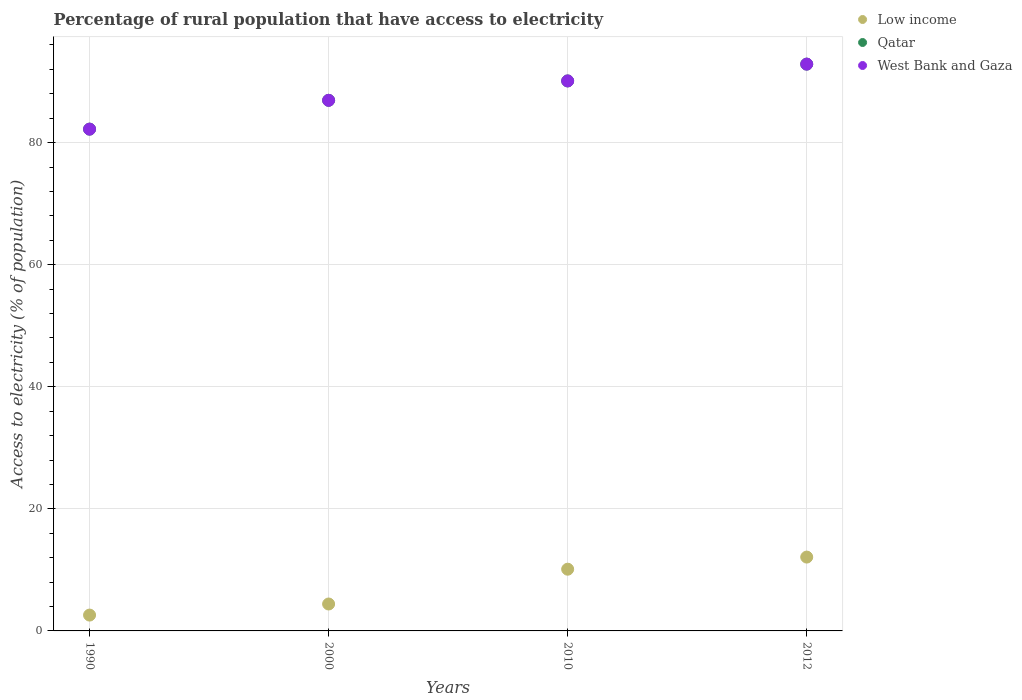Is the number of dotlines equal to the number of legend labels?
Your response must be concise. Yes. What is the percentage of rural population that have access to electricity in Low income in 2000?
Provide a succinct answer. 4.41. Across all years, what is the maximum percentage of rural population that have access to electricity in West Bank and Gaza?
Offer a very short reply. 92.85. Across all years, what is the minimum percentage of rural population that have access to electricity in Qatar?
Give a very brief answer. 82.2. In which year was the percentage of rural population that have access to electricity in West Bank and Gaza minimum?
Your answer should be compact. 1990. What is the total percentage of rural population that have access to electricity in West Bank and Gaza in the graph?
Provide a short and direct response. 352.08. What is the difference between the percentage of rural population that have access to electricity in Qatar in 2000 and that in 2012?
Your answer should be very brief. -5.93. What is the difference between the percentage of rural population that have access to electricity in West Bank and Gaza in 2000 and the percentage of rural population that have access to electricity in Qatar in 1990?
Keep it short and to the point. 4.72. What is the average percentage of rural population that have access to electricity in Qatar per year?
Ensure brevity in your answer.  88.02. In the year 2010, what is the difference between the percentage of rural population that have access to electricity in Low income and percentage of rural population that have access to electricity in Qatar?
Provide a short and direct response. -79.99. In how many years, is the percentage of rural population that have access to electricity in West Bank and Gaza greater than 84 %?
Your answer should be compact. 3. What is the ratio of the percentage of rural population that have access to electricity in Low income in 2010 to that in 2012?
Provide a succinct answer. 0.84. What is the difference between the highest and the second highest percentage of rural population that have access to electricity in Low income?
Offer a very short reply. 1.98. What is the difference between the highest and the lowest percentage of rural population that have access to electricity in Low income?
Make the answer very short. 9.5. In how many years, is the percentage of rural population that have access to electricity in Low income greater than the average percentage of rural population that have access to electricity in Low income taken over all years?
Keep it short and to the point. 2. Is it the case that in every year, the sum of the percentage of rural population that have access to electricity in Low income and percentage of rural population that have access to electricity in Qatar  is greater than the percentage of rural population that have access to electricity in West Bank and Gaza?
Your response must be concise. Yes. Does the percentage of rural population that have access to electricity in West Bank and Gaza monotonically increase over the years?
Your answer should be compact. Yes. Is the percentage of rural population that have access to electricity in Qatar strictly greater than the percentage of rural population that have access to electricity in Low income over the years?
Keep it short and to the point. Yes. How many years are there in the graph?
Offer a very short reply. 4. What is the difference between two consecutive major ticks on the Y-axis?
Your response must be concise. 20. Are the values on the major ticks of Y-axis written in scientific E-notation?
Keep it short and to the point. No. Does the graph contain grids?
Provide a short and direct response. Yes. How are the legend labels stacked?
Provide a succinct answer. Vertical. What is the title of the graph?
Offer a terse response. Percentage of rural population that have access to electricity. What is the label or title of the Y-axis?
Your answer should be very brief. Access to electricity (% of population). What is the Access to electricity (% of population) of Low income in 1990?
Make the answer very short. 2.6. What is the Access to electricity (% of population) in Qatar in 1990?
Provide a short and direct response. 82.2. What is the Access to electricity (% of population) in West Bank and Gaza in 1990?
Your answer should be compact. 82.2. What is the Access to electricity (% of population) of Low income in 2000?
Provide a succinct answer. 4.41. What is the Access to electricity (% of population) in Qatar in 2000?
Your answer should be compact. 86.93. What is the Access to electricity (% of population) of West Bank and Gaza in 2000?
Offer a terse response. 86.93. What is the Access to electricity (% of population) of Low income in 2010?
Provide a short and direct response. 10.11. What is the Access to electricity (% of population) in Qatar in 2010?
Offer a very short reply. 90.1. What is the Access to electricity (% of population) of West Bank and Gaza in 2010?
Ensure brevity in your answer.  90.1. What is the Access to electricity (% of population) in Low income in 2012?
Provide a succinct answer. 12.1. What is the Access to electricity (% of population) in Qatar in 2012?
Keep it short and to the point. 92.85. What is the Access to electricity (% of population) in West Bank and Gaza in 2012?
Give a very brief answer. 92.85. Across all years, what is the maximum Access to electricity (% of population) in Low income?
Make the answer very short. 12.1. Across all years, what is the maximum Access to electricity (% of population) in Qatar?
Keep it short and to the point. 92.85. Across all years, what is the maximum Access to electricity (% of population) of West Bank and Gaza?
Offer a terse response. 92.85. Across all years, what is the minimum Access to electricity (% of population) of Low income?
Provide a succinct answer. 2.6. Across all years, what is the minimum Access to electricity (% of population) of Qatar?
Keep it short and to the point. 82.2. Across all years, what is the minimum Access to electricity (% of population) in West Bank and Gaza?
Keep it short and to the point. 82.2. What is the total Access to electricity (% of population) in Low income in the graph?
Keep it short and to the point. 29.21. What is the total Access to electricity (% of population) in Qatar in the graph?
Offer a terse response. 352.08. What is the total Access to electricity (% of population) in West Bank and Gaza in the graph?
Provide a succinct answer. 352.08. What is the difference between the Access to electricity (% of population) in Low income in 1990 and that in 2000?
Your response must be concise. -1.82. What is the difference between the Access to electricity (% of population) of Qatar in 1990 and that in 2000?
Provide a short and direct response. -4.72. What is the difference between the Access to electricity (% of population) in West Bank and Gaza in 1990 and that in 2000?
Ensure brevity in your answer.  -4.72. What is the difference between the Access to electricity (% of population) of Low income in 1990 and that in 2010?
Provide a short and direct response. -7.52. What is the difference between the Access to electricity (% of population) of Qatar in 1990 and that in 2010?
Provide a short and direct response. -7.9. What is the difference between the Access to electricity (% of population) in West Bank and Gaza in 1990 and that in 2010?
Offer a very short reply. -7.9. What is the difference between the Access to electricity (% of population) of Low income in 1990 and that in 2012?
Offer a terse response. -9.5. What is the difference between the Access to electricity (% of population) of Qatar in 1990 and that in 2012?
Your answer should be compact. -10.65. What is the difference between the Access to electricity (% of population) of West Bank and Gaza in 1990 and that in 2012?
Keep it short and to the point. -10.65. What is the difference between the Access to electricity (% of population) in Low income in 2000 and that in 2010?
Ensure brevity in your answer.  -5.7. What is the difference between the Access to electricity (% of population) of Qatar in 2000 and that in 2010?
Your response must be concise. -3.17. What is the difference between the Access to electricity (% of population) in West Bank and Gaza in 2000 and that in 2010?
Your answer should be very brief. -3.17. What is the difference between the Access to electricity (% of population) in Low income in 2000 and that in 2012?
Your answer should be very brief. -7.69. What is the difference between the Access to electricity (% of population) of Qatar in 2000 and that in 2012?
Give a very brief answer. -5.93. What is the difference between the Access to electricity (% of population) of West Bank and Gaza in 2000 and that in 2012?
Your answer should be very brief. -5.93. What is the difference between the Access to electricity (% of population) of Low income in 2010 and that in 2012?
Offer a very short reply. -1.98. What is the difference between the Access to electricity (% of population) in Qatar in 2010 and that in 2012?
Offer a very short reply. -2.75. What is the difference between the Access to electricity (% of population) in West Bank and Gaza in 2010 and that in 2012?
Offer a terse response. -2.75. What is the difference between the Access to electricity (% of population) in Low income in 1990 and the Access to electricity (% of population) in Qatar in 2000?
Keep it short and to the point. -84.33. What is the difference between the Access to electricity (% of population) in Low income in 1990 and the Access to electricity (% of population) in West Bank and Gaza in 2000?
Provide a succinct answer. -84.33. What is the difference between the Access to electricity (% of population) in Qatar in 1990 and the Access to electricity (% of population) in West Bank and Gaza in 2000?
Your answer should be compact. -4.72. What is the difference between the Access to electricity (% of population) of Low income in 1990 and the Access to electricity (% of population) of Qatar in 2010?
Keep it short and to the point. -87.5. What is the difference between the Access to electricity (% of population) in Low income in 1990 and the Access to electricity (% of population) in West Bank and Gaza in 2010?
Offer a terse response. -87.5. What is the difference between the Access to electricity (% of population) in Qatar in 1990 and the Access to electricity (% of population) in West Bank and Gaza in 2010?
Ensure brevity in your answer.  -7.9. What is the difference between the Access to electricity (% of population) of Low income in 1990 and the Access to electricity (% of population) of Qatar in 2012?
Your response must be concise. -90.26. What is the difference between the Access to electricity (% of population) in Low income in 1990 and the Access to electricity (% of population) in West Bank and Gaza in 2012?
Give a very brief answer. -90.26. What is the difference between the Access to electricity (% of population) in Qatar in 1990 and the Access to electricity (% of population) in West Bank and Gaza in 2012?
Provide a succinct answer. -10.65. What is the difference between the Access to electricity (% of population) of Low income in 2000 and the Access to electricity (% of population) of Qatar in 2010?
Your response must be concise. -85.69. What is the difference between the Access to electricity (% of population) of Low income in 2000 and the Access to electricity (% of population) of West Bank and Gaza in 2010?
Give a very brief answer. -85.69. What is the difference between the Access to electricity (% of population) of Qatar in 2000 and the Access to electricity (% of population) of West Bank and Gaza in 2010?
Your answer should be compact. -3.17. What is the difference between the Access to electricity (% of population) of Low income in 2000 and the Access to electricity (% of population) of Qatar in 2012?
Give a very brief answer. -88.44. What is the difference between the Access to electricity (% of population) of Low income in 2000 and the Access to electricity (% of population) of West Bank and Gaza in 2012?
Offer a terse response. -88.44. What is the difference between the Access to electricity (% of population) in Qatar in 2000 and the Access to electricity (% of population) in West Bank and Gaza in 2012?
Give a very brief answer. -5.93. What is the difference between the Access to electricity (% of population) in Low income in 2010 and the Access to electricity (% of population) in Qatar in 2012?
Provide a short and direct response. -82.74. What is the difference between the Access to electricity (% of population) of Low income in 2010 and the Access to electricity (% of population) of West Bank and Gaza in 2012?
Your answer should be very brief. -82.74. What is the difference between the Access to electricity (% of population) of Qatar in 2010 and the Access to electricity (% of population) of West Bank and Gaza in 2012?
Provide a succinct answer. -2.75. What is the average Access to electricity (% of population) in Low income per year?
Ensure brevity in your answer.  7.3. What is the average Access to electricity (% of population) of Qatar per year?
Your response must be concise. 88.02. What is the average Access to electricity (% of population) in West Bank and Gaza per year?
Offer a terse response. 88.02. In the year 1990, what is the difference between the Access to electricity (% of population) of Low income and Access to electricity (% of population) of Qatar?
Keep it short and to the point. -79.61. In the year 1990, what is the difference between the Access to electricity (% of population) in Low income and Access to electricity (% of population) in West Bank and Gaza?
Offer a terse response. -79.61. In the year 1990, what is the difference between the Access to electricity (% of population) of Qatar and Access to electricity (% of population) of West Bank and Gaza?
Your answer should be very brief. 0. In the year 2000, what is the difference between the Access to electricity (% of population) of Low income and Access to electricity (% of population) of Qatar?
Keep it short and to the point. -82.52. In the year 2000, what is the difference between the Access to electricity (% of population) of Low income and Access to electricity (% of population) of West Bank and Gaza?
Your response must be concise. -82.52. In the year 2010, what is the difference between the Access to electricity (% of population) in Low income and Access to electricity (% of population) in Qatar?
Offer a very short reply. -79.99. In the year 2010, what is the difference between the Access to electricity (% of population) of Low income and Access to electricity (% of population) of West Bank and Gaza?
Provide a succinct answer. -79.99. In the year 2010, what is the difference between the Access to electricity (% of population) in Qatar and Access to electricity (% of population) in West Bank and Gaza?
Provide a short and direct response. 0. In the year 2012, what is the difference between the Access to electricity (% of population) in Low income and Access to electricity (% of population) in Qatar?
Your answer should be compact. -80.76. In the year 2012, what is the difference between the Access to electricity (% of population) of Low income and Access to electricity (% of population) of West Bank and Gaza?
Your answer should be very brief. -80.76. In the year 2012, what is the difference between the Access to electricity (% of population) of Qatar and Access to electricity (% of population) of West Bank and Gaza?
Provide a succinct answer. 0. What is the ratio of the Access to electricity (% of population) in Low income in 1990 to that in 2000?
Give a very brief answer. 0.59. What is the ratio of the Access to electricity (% of population) of Qatar in 1990 to that in 2000?
Your answer should be very brief. 0.95. What is the ratio of the Access to electricity (% of population) of West Bank and Gaza in 1990 to that in 2000?
Ensure brevity in your answer.  0.95. What is the ratio of the Access to electricity (% of population) of Low income in 1990 to that in 2010?
Make the answer very short. 0.26. What is the ratio of the Access to electricity (% of population) in Qatar in 1990 to that in 2010?
Your answer should be compact. 0.91. What is the ratio of the Access to electricity (% of population) in West Bank and Gaza in 1990 to that in 2010?
Your answer should be very brief. 0.91. What is the ratio of the Access to electricity (% of population) in Low income in 1990 to that in 2012?
Your answer should be very brief. 0.21. What is the ratio of the Access to electricity (% of population) of Qatar in 1990 to that in 2012?
Your answer should be compact. 0.89. What is the ratio of the Access to electricity (% of population) in West Bank and Gaza in 1990 to that in 2012?
Your answer should be very brief. 0.89. What is the ratio of the Access to electricity (% of population) in Low income in 2000 to that in 2010?
Provide a short and direct response. 0.44. What is the ratio of the Access to electricity (% of population) in Qatar in 2000 to that in 2010?
Offer a terse response. 0.96. What is the ratio of the Access to electricity (% of population) of West Bank and Gaza in 2000 to that in 2010?
Your answer should be very brief. 0.96. What is the ratio of the Access to electricity (% of population) in Low income in 2000 to that in 2012?
Make the answer very short. 0.36. What is the ratio of the Access to electricity (% of population) in Qatar in 2000 to that in 2012?
Ensure brevity in your answer.  0.94. What is the ratio of the Access to electricity (% of population) of West Bank and Gaza in 2000 to that in 2012?
Offer a terse response. 0.94. What is the ratio of the Access to electricity (% of population) in Low income in 2010 to that in 2012?
Offer a very short reply. 0.84. What is the ratio of the Access to electricity (% of population) of Qatar in 2010 to that in 2012?
Provide a short and direct response. 0.97. What is the ratio of the Access to electricity (% of population) of West Bank and Gaza in 2010 to that in 2012?
Provide a succinct answer. 0.97. What is the difference between the highest and the second highest Access to electricity (% of population) of Low income?
Keep it short and to the point. 1.98. What is the difference between the highest and the second highest Access to electricity (% of population) in Qatar?
Make the answer very short. 2.75. What is the difference between the highest and the second highest Access to electricity (% of population) in West Bank and Gaza?
Give a very brief answer. 2.75. What is the difference between the highest and the lowest Access to electricity (% of population) in Low income?
Your answer should be compact. 9.5. What is the difference between the highest and the lowest Access to electricity (% of population) in Qatar?
Keep it short and to the point. 10.65. What is the difference between the highest and the lowest Access to electricity (% of population) of West Bank and Gaza?
Make the answer very short. 10.65. 